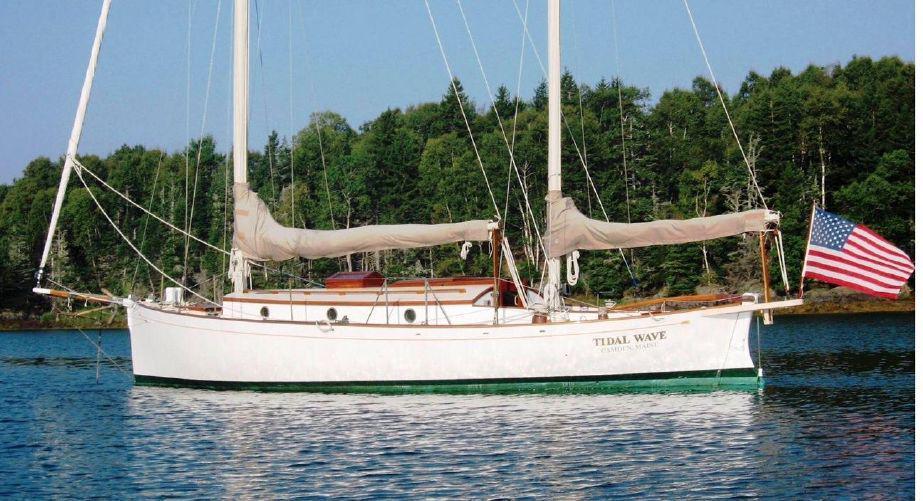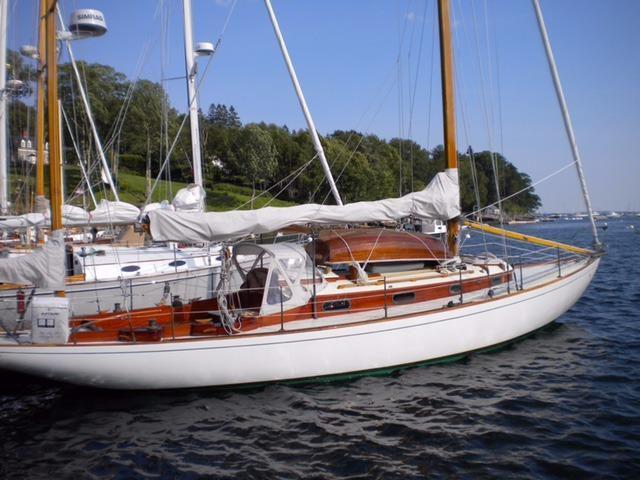The first image is the image on the left, the second image is the image on the right. Assess this claim about the two images: "All images show white-bodied boats, and no boat has its sails unfurled.". Correct or not? Answer yes or no. Yes. The first image is the image on the left, the second image is the image on the right. Considering the images on both sides, is "Both sailboats have furled white sails." valid? Answer yes or no. Yes. 